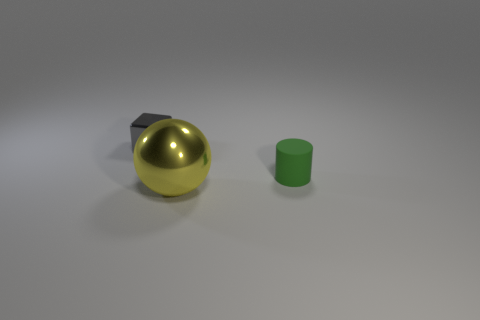How big is the metallic object to the left of the metal thing that is in front of the green rubber cylinder?
Your answer should be very brief. Small. There is a shiny object behind the green rubber thing; what is its size?
Your answer should be compact. Small. Is the number of large yellow objects that are in front of the large metallic sphere less than the number of tiny green matte things that are behind the small gray block?
Offer a terse response. No. What color is the big shiny thing?
Your response must be concise. Yellow. Are there any tiny matte things of the same color as the tiny cylinder?
Provide a succinct answer. No. What is the shape of the small object behind the tiny object on the right side of the object that is behind the rubber cylinder?
Provide a succinct answer. Cube. What material is the object that is in front of the tiny cylinder?
Ensure brevity in your answer.  Metal. There is a object on the right side of the metallic thing in front of the metal thing that is behind the big yellow sphere; how big is it?
Provide a succinct answer. Small. There is a gray thing; is it the same size as the metal thing in front of the gray metallic thing?
Ensure brevity in your answer.  No. What is the color of the thing that is in front of the small green cylinder?
Keep it short and to the point. Yellow. 